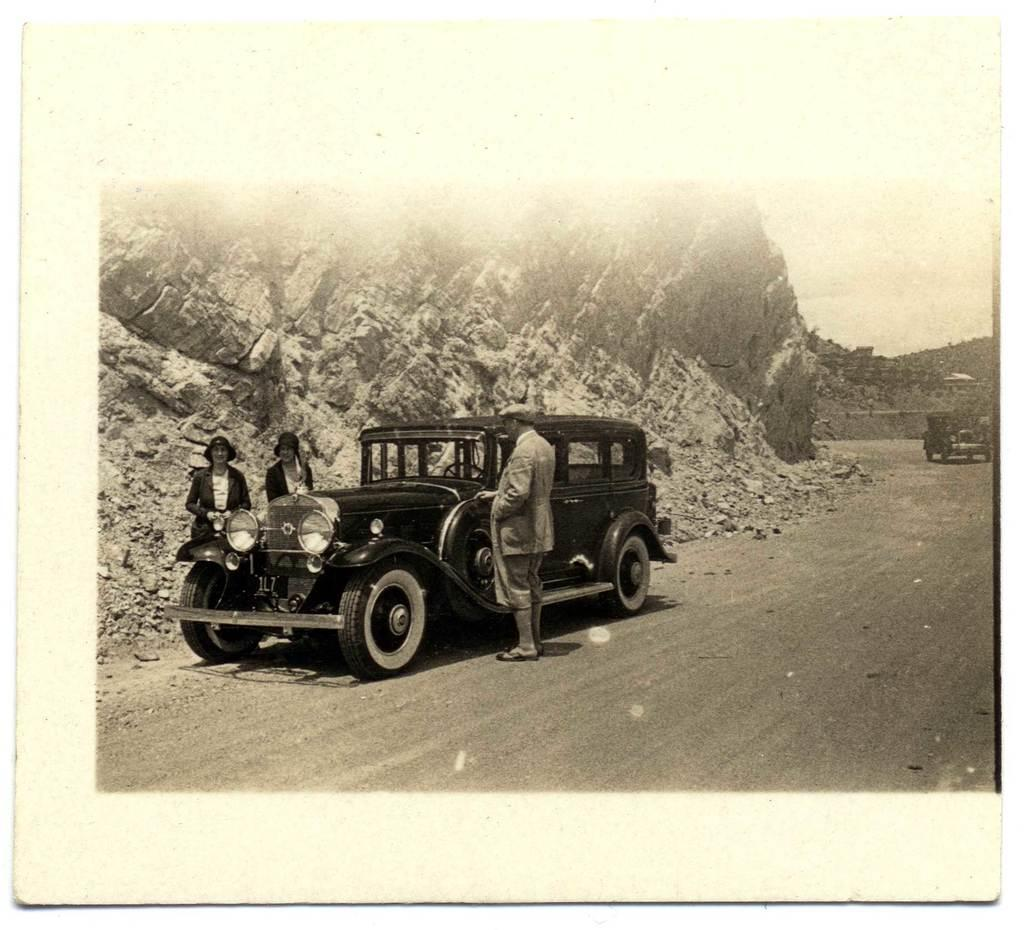What is the color scheme of the image? The image is black and white. What can be seen on the road in the image? There are vehicles on the road. How many people are standing beside a vehicle in the image? Three people are standing beside a vehicle. What type of structure is present in the image? There is a rock wall in the image. What is the weight of the grass in the image? There is no grass present in the image, so it is not possible to determine its weight. 